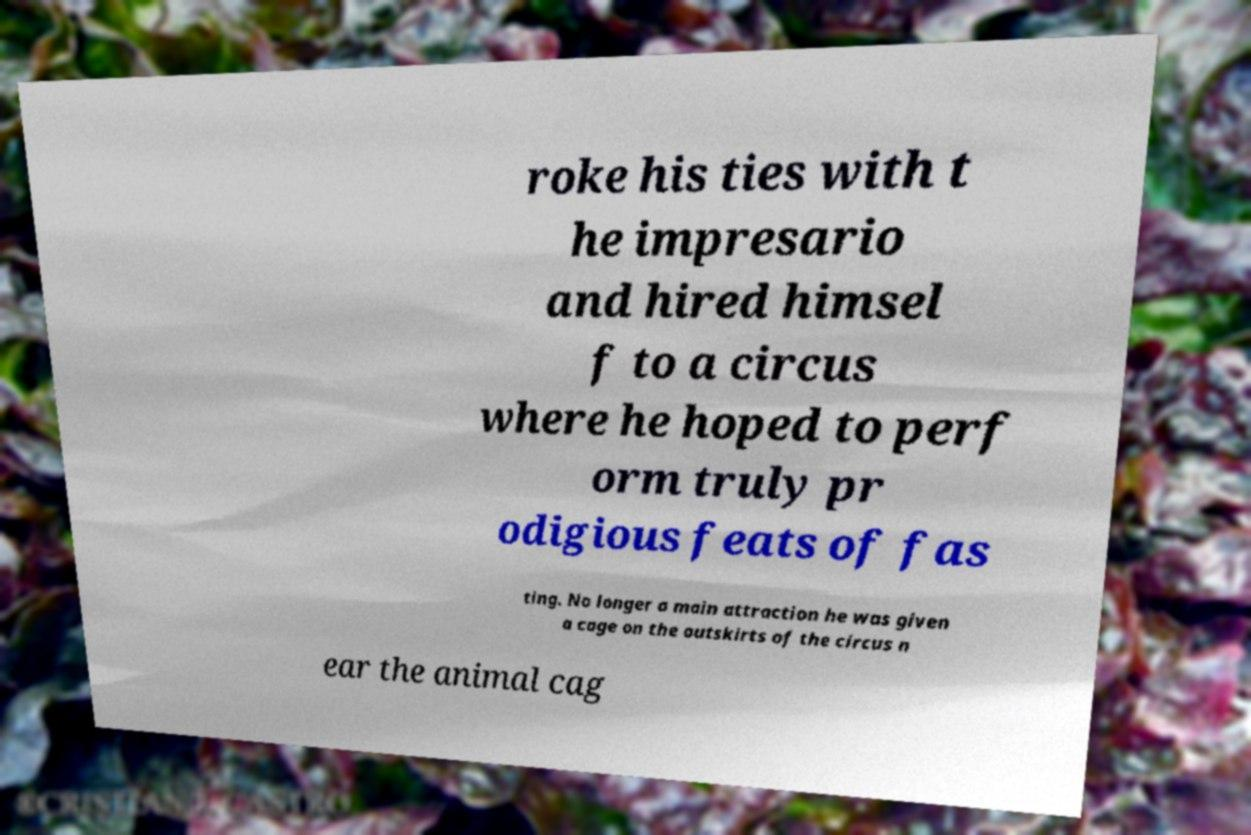For documentation purposes, I need the text within this image transcribed. Could you provide that? roke his ties with t he impresario and hired himsel f to a circus where he hoped to perf orm truly pr odigious feats of fas ting. No longer a main attraction he was given a cage on the outskirts of the circus n ear the animal cag 